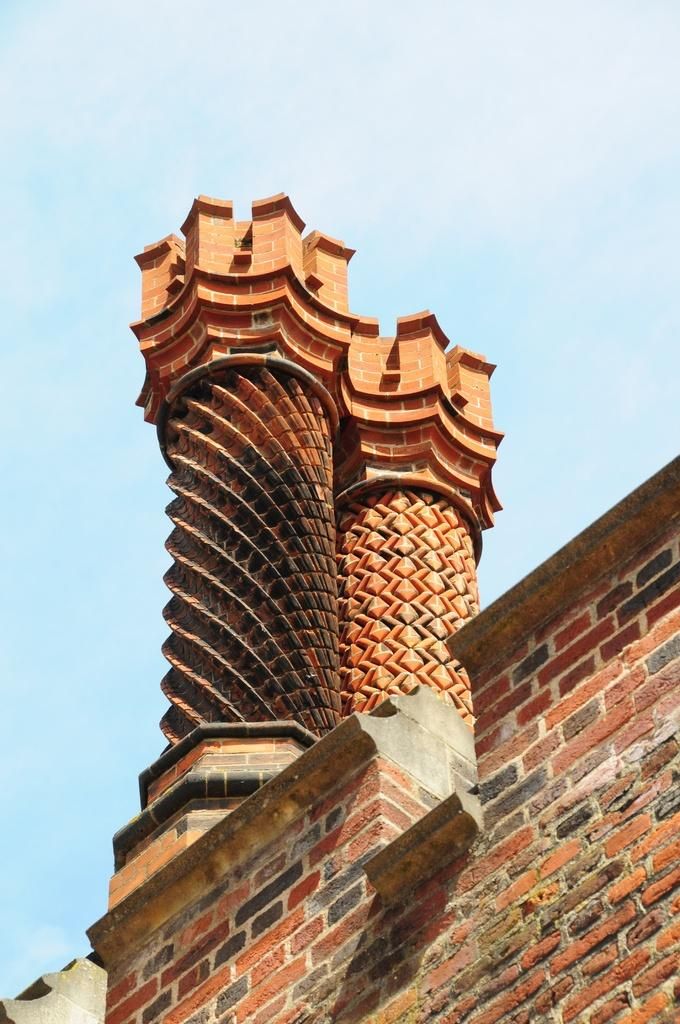What is the main structure in the image? There is a monument in the image. What type of material is used for the wall at the bottom of the image? The wall at the bottom of the image is made of bricks. What can be seen at the top of the image? The sky is visible at the top of the image. What is present in the sky? Clouds are present in the sky. How many snakes are slithering around the monument in the image? There are no snakes present in the image. Can you locate a map on the monument in the image? There is no map present on the monument in the image. 